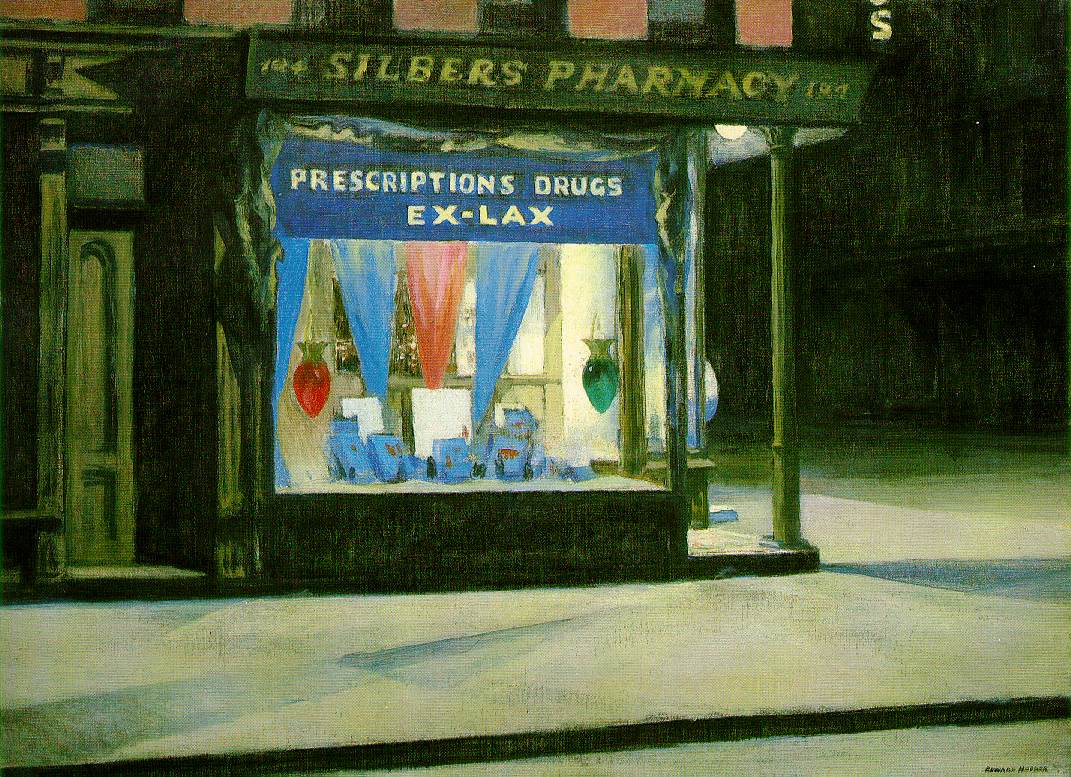Imagine this is part of a city full of such beautifully lit shops. How would the atmosphere and overall appeal of the city change? If the city were filled with beautifully lit shops like Silber's Pharmacy, the atmosphere would be transformed into a vibrant and enchanting nocturnal landscape. Each shop, with its unique display of lights and colors, would contribute to a kaleidoscope of visual interest, turning the city's streets into a breathtaking tapestry of illumination. The night would no longer be perceived as a time of dormancy but as a celebration of creativity and life.

Walking through these streets would feel like strolling through a wonderland, with each brightly lit window telling its own story. The interplay of lights would create intricate patterns of shadows, adding depth and richness to the urban environment. This would attract both locals and tourists, eager to experience the city's night-time charm, fostering a sense of pride within the community and boosting the local economy.

The city's appeal would extend beyond its practical functions, offering an inviting escape into a world of light and imagination, where every corner holds a new visual delight waiting to be discovered. This unique ambiance could become a defining characteristic of the city, attracting visitors from far and wide to experience its nocturnal beauty. 